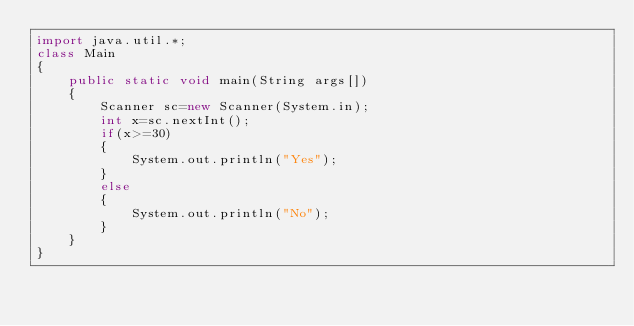Convert code to text. <code><loc_0><loc_0><loc_500><loc_500><_Java_>import java.util.*;
class Main
{
    public static void main(String args[])
    {
        Scanner sc=new Scanner(System.in);
        int x=sc.nextInt();
        if(x>=30)
        {
            System.out.println("Yes");
        }
        else
        {
            System.out.println("No");
        }
    }
}</code> 